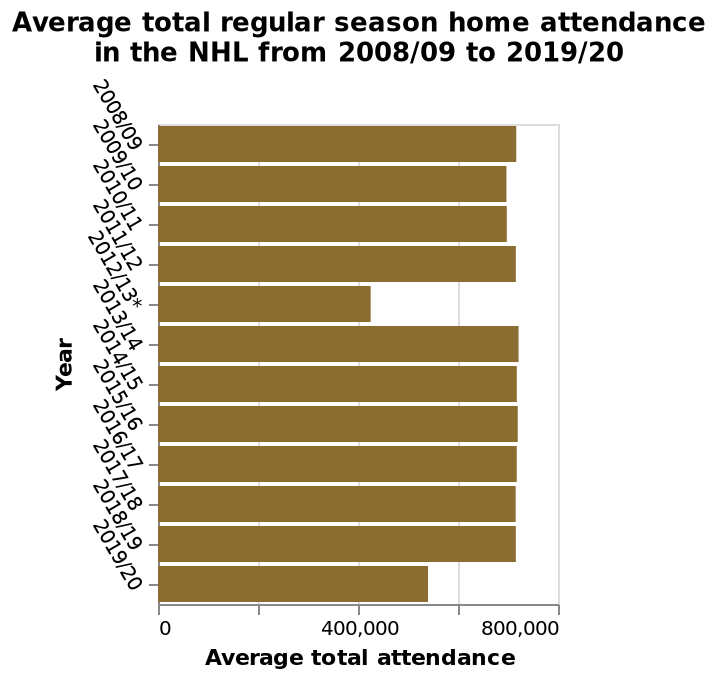<image>
How is the y-axis labeled in the bar diagram? The y-axis is labeled as "Year" using a categorical scale from 2008/09 to 2019/20. 